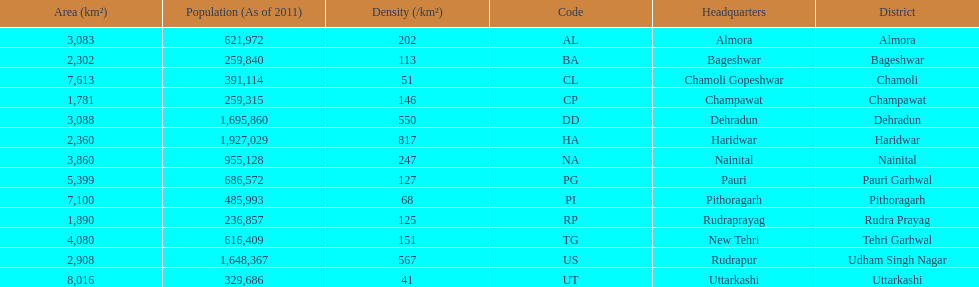Which has a larger population, dehradun or nainital? Dehradun. 